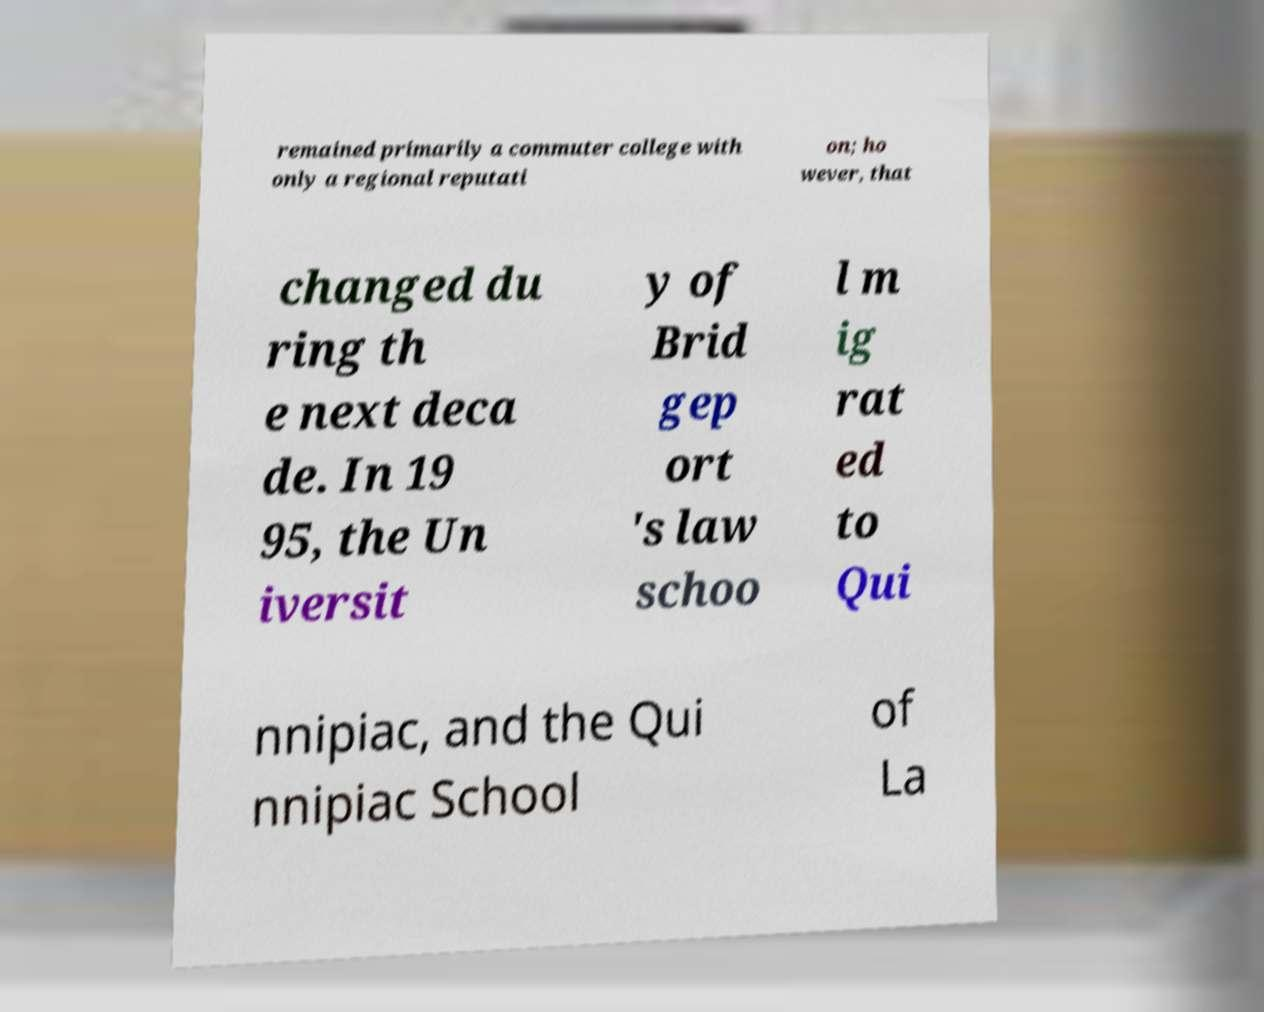There's text embedded in this image that I need extracted. Can you transcribe it verbatim? remained primarily a commuter college with only a regional reputati on; ho wever, that changed du ring th e next deca de. In 19 95, the Un iversit y of Brid gep ort 's law schoo l m ig rat ed to Qui nnipiac, and the Qui nnipiac School of La 